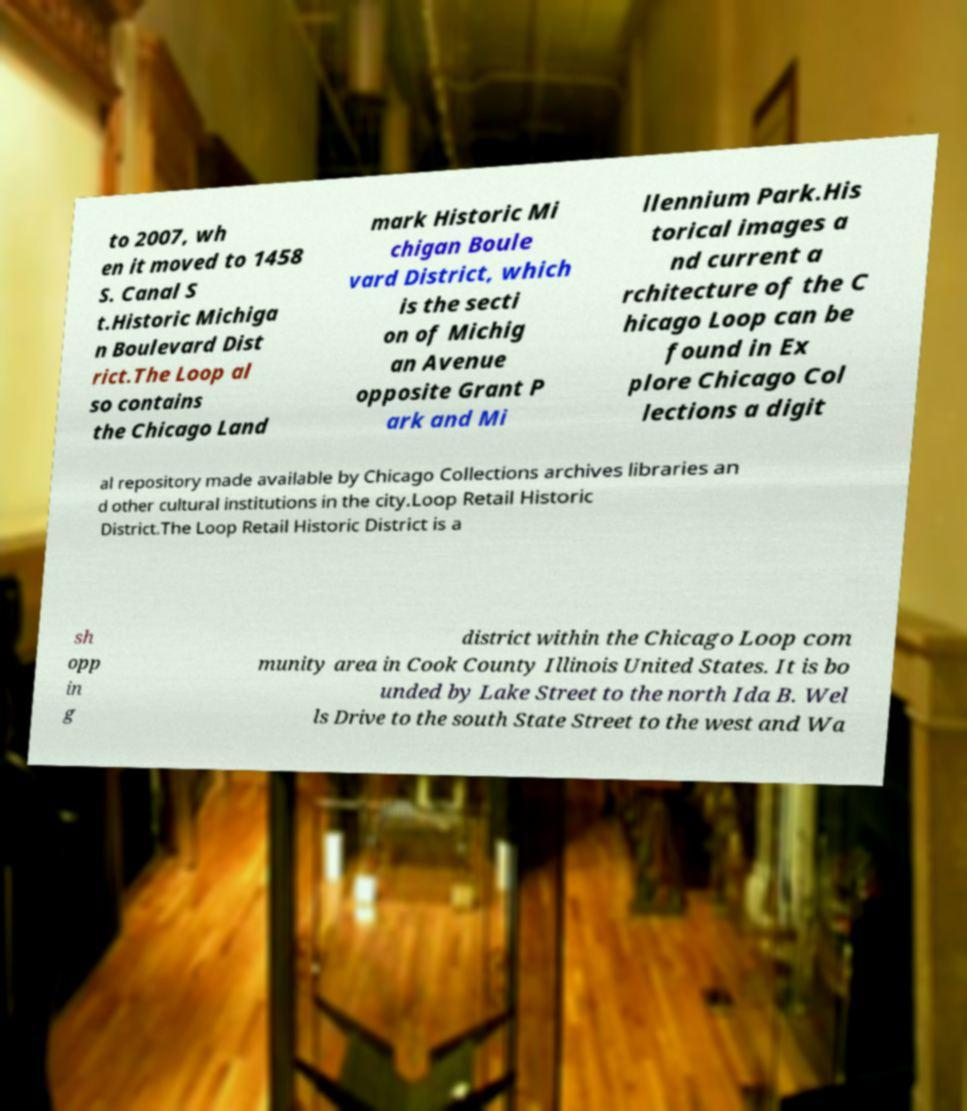I need the written content from this picture converted into text. Can you do that? to 2007, wh en it moved to 1458 S. Canal S t.Historic Michiga n Boulevard Dist rict.The Loop al so contains the Chicago Land mark Historic Mi chigan Boule vard District, which is the secti on of Michig an Avenue opposite Grant P ark and Mi llennium Park.His torical images a nd current a rchitecture of the C hicago Loop can be found in Ex plore Chicago Col lections a digit al repository made available by Chicago Collections archives libraries an d other cultural institutions in the city.Loop Retail Historic District.The Loop Retail Historic District is a sh opp in g district within the Chicago Loop com munity area in Cook County Illinois United States. It is bo unded by Lake Street to the north Ida B. Wel ls Drive to the south State Street to the west and Wa 